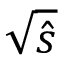<formula> <loc_0><loc_0><loc_500><loc_500>\sqrt { \hat { s } }</formula> 